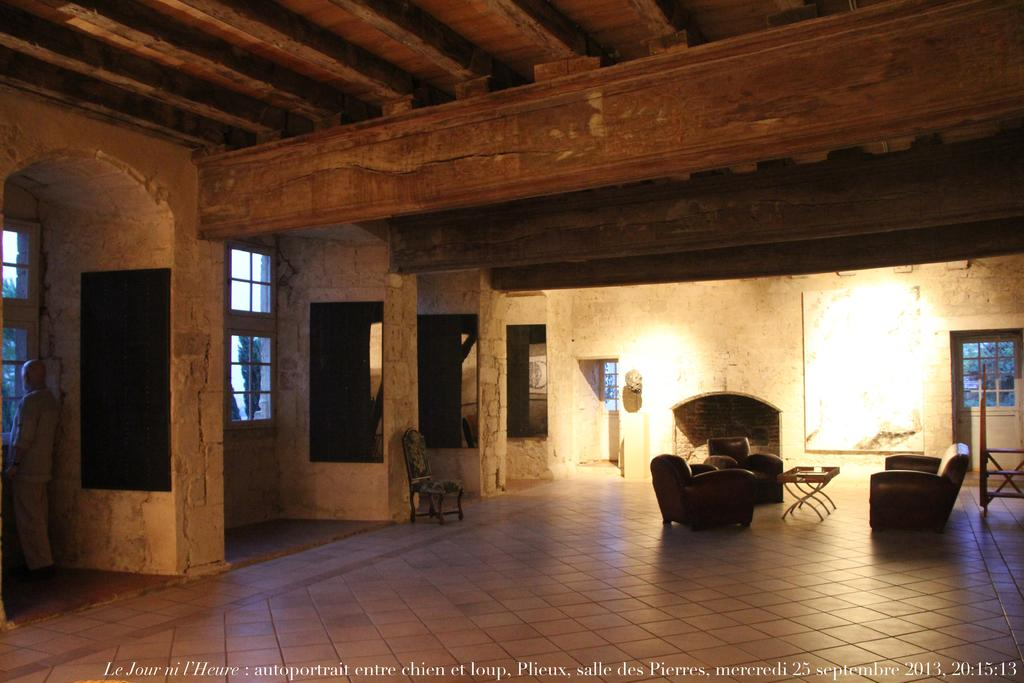What type of furniture is present in the image? There is a sofa, chairs, and a table in the image. What is on the wall in the image? There is a big banner on the wall. Can you describe the placement of the chair near a pillar? Yes, there is a chair near a pillar in the image. What type of voice can be heard coming from the banner in the image? There is no voice coming from the banner in the image, as it is a static object. 